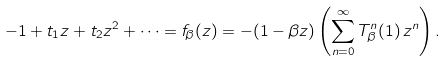Convert formula to latex. <formula><loc_0><loc_0><loc_500><loc_500>- 1 + t _ { 1 } z + t _ { 2 } z ^ { 2 } + \dots = f _ { \beta } ( z ) = - ( 1 - \beta z ) \left ( \sum _ { n = 0 } ^ { \infty } T _ { \beta } ^ { n } ( 1 ) \, z ^ { n } \right ) .</formula> 